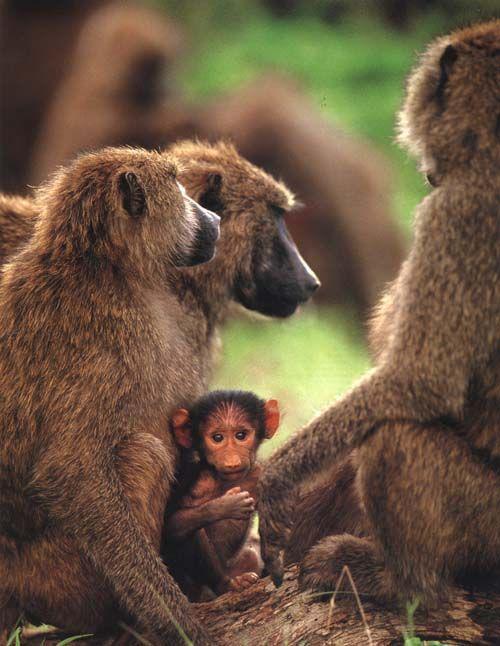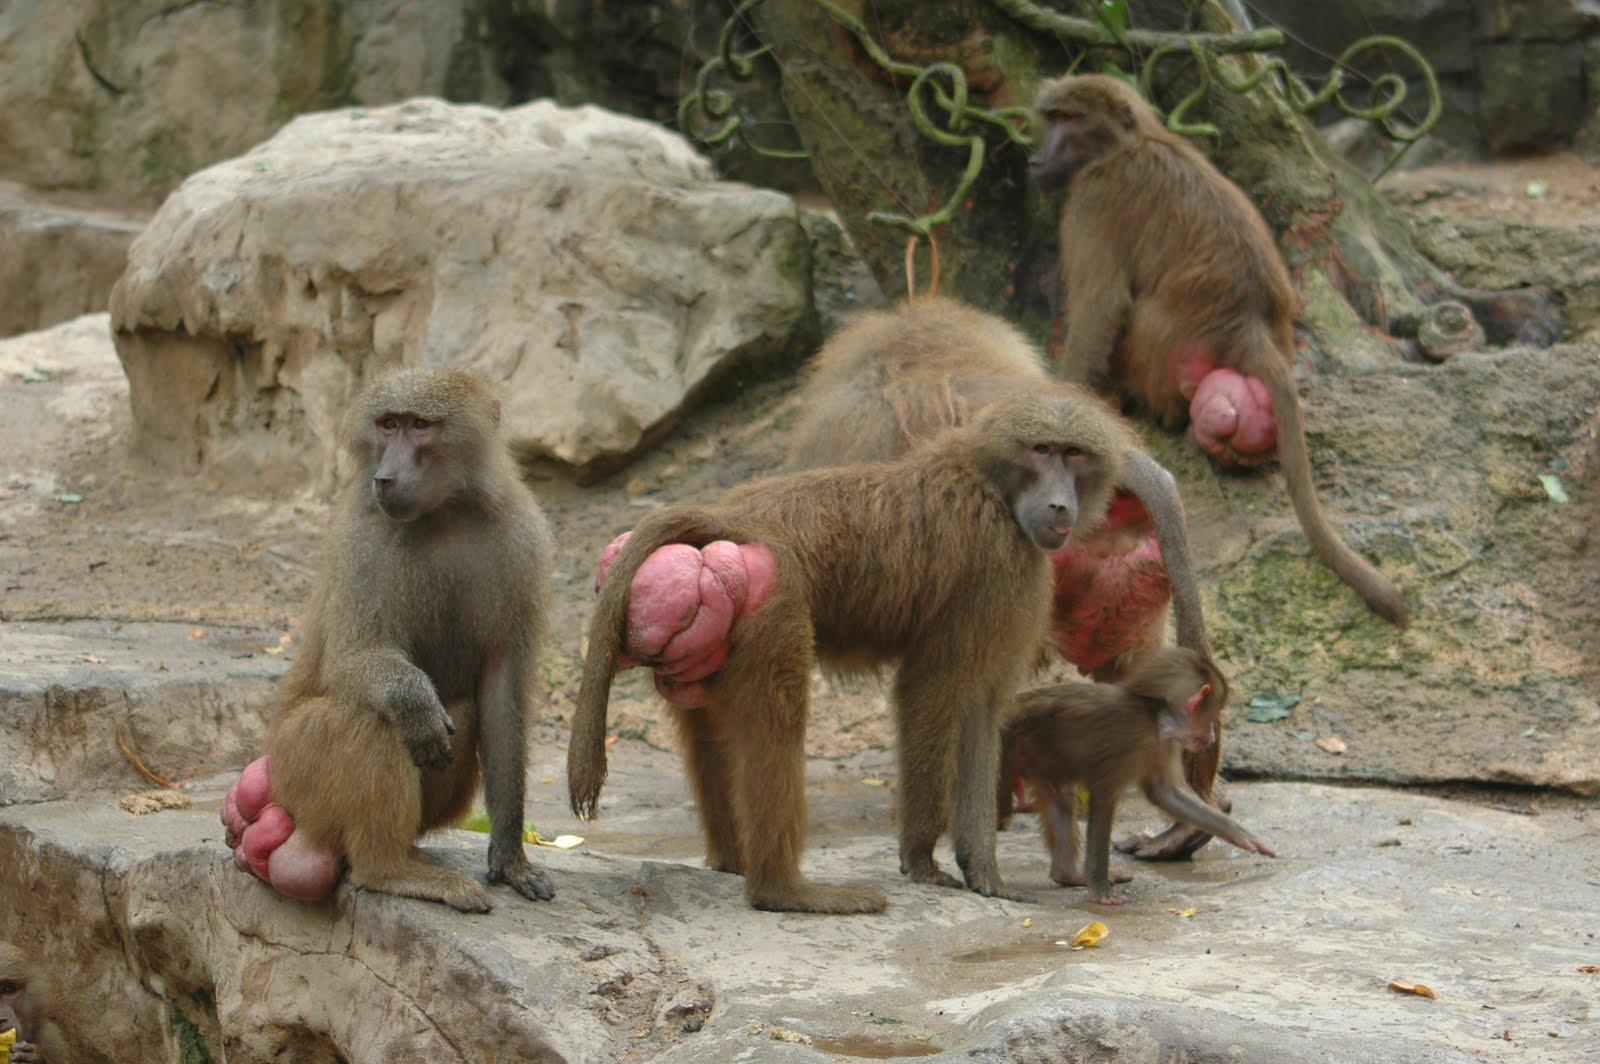The first image is the image on the left, the second image is the image on the right. Assess this claim about the two images: "Humorous memes about baboons". Correct or not? Answer yes or no. No. 